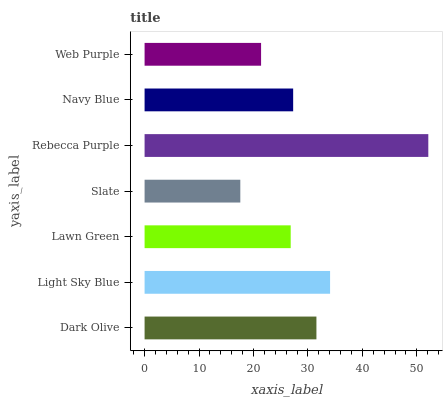Is Slate the minimum?
Answer yes or no. Yes. Is Rebecca Purple the maximum?
Answer yes or no. Yes. Is Light Sky Blue the minimum?
Answer yes or no. No. Is Light Sky Blue the maximum?
Answer yes or no. No. Is Light Sky Blue greater than Dark Olive?
Answer yes or no. Yes. Is Dark Olive less than Light Sky Blue?
Answer yes or no. Yes. Is Dark Olive greater than Light Sky Blue?
Answer yes or no. No. Is Light Sky Blue less than Dark Olive?
Answer yes or no. No. Is Navy Blue the high median?
Answer yes or no. Yes. Is Navy Blue the low median?
Answer yes or no. Yes. Is Light Sky Blue the high median?
Answer yes or no. No. Is Rebecca Purple the low median?
Answer yes or no. No. 